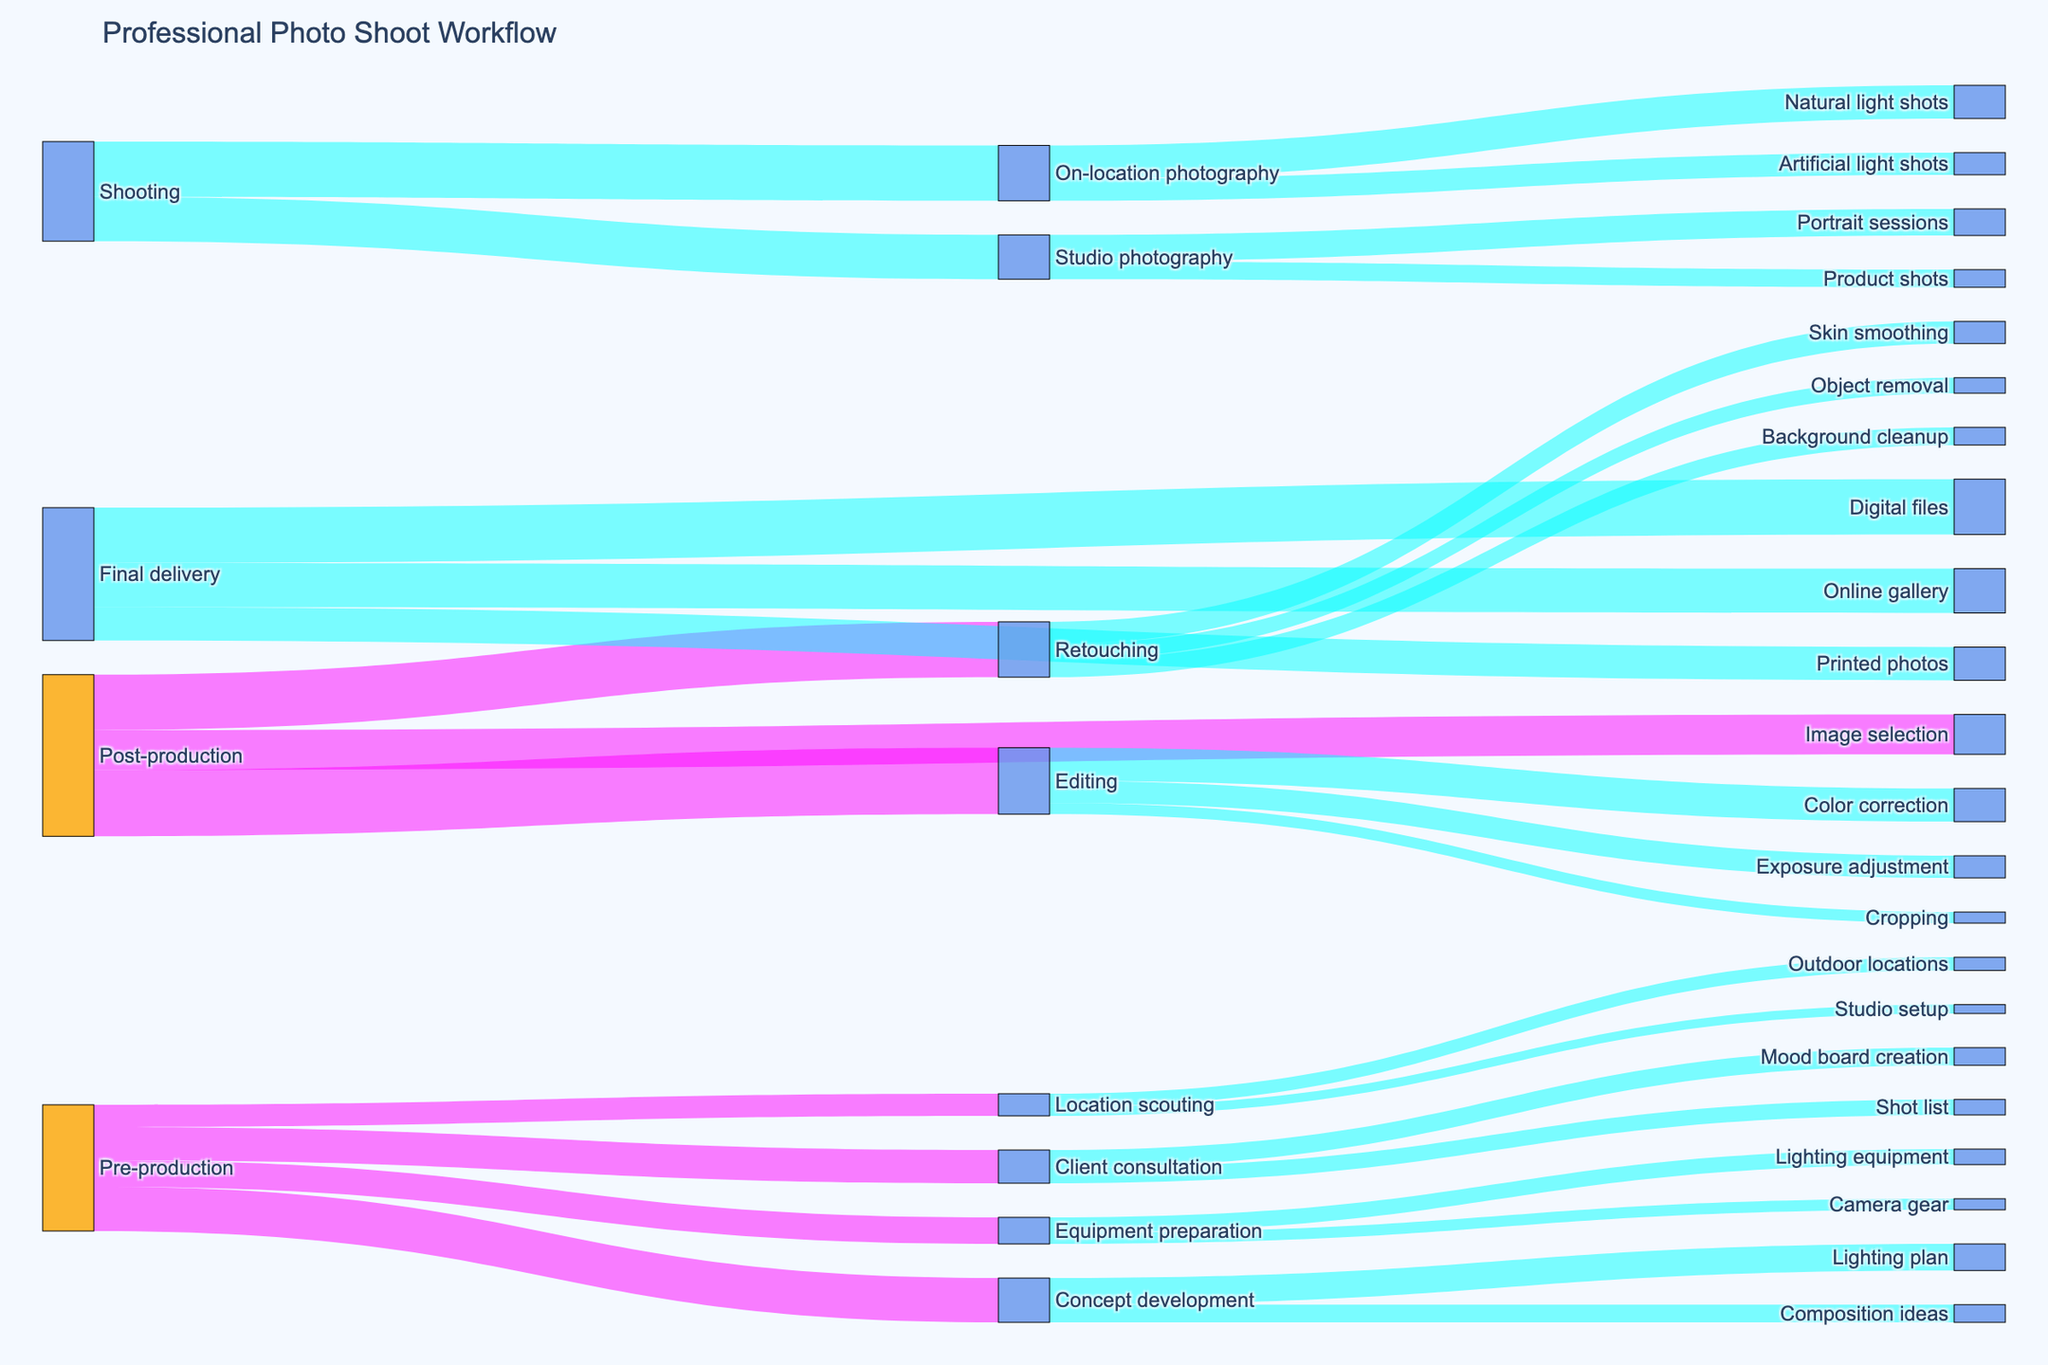What is the title of the Sankey diagram? The title is usually placed at the top of the diagram and describes the overall subject of the visualization.
Answer: Professional Photo Shoot Workflow Which two steps in pre-production have the highest values? By examining the connections originating from the pre-production node, you can identify the values associated with each sub-step. The highest values are Concept development (20) and Client consultation (15).
Answer: Concept development and Client consultation How many connections are there in total from Pre-production to subsequent steps? By counting the arrows originating from the Pre-production node, we can tally the total number of direct connections. There are four connections: Location scouting, Client consultation, Concept development, and Equipment preparation.
Answer: 4 Summing up all the values, what is the total flow from Post-production? The flows from Post-production lead to three target nodes: Image selection (18), Editing (30), and Retouching (25). Adding these values gives 18 + 30 + 25 = 73.
Answer: 73 Compare On-location photography and Studio photography: which has a higher total flow and by how much? We add the values of sub-flows for each type. On-location photography has 15 (Natural light) + 10 (Artificial light) = 25. Studio photography has 12 (Portrait sessions) + 8 (Product shots) = 20. Thus, On-location photography is higher by 25 - 20 = 5.
Answer: On-location photography by 5 Which step has the highest individual flow value in the entire workflow? We need to look for the largest number associated with any single flow. The highest value is 30, from Post-production to Editing.
Answer: Editing What are the two final delivery methods with the highest values? By examining the values associated with the connections to Final delivery, the two largest values are Digital files (25) and Online gallery (20).
Answer: Digital files and Online gallery What is the total value associated with Retouching activities? Adding up all values for the Retouching targets: Skin smoothing (10), Background cleanup (8), and Object removal (7), we get 10 + 8 + 7 = 25.
Answer: 25 If we remove Equipment preparation, what would be the new total value for Pre-production flows? The current total for Pre-production flows is 10 (Location scouting) + 15 (Client consultation) + 20 (Concept development) + 12 (Equipment preparation) = 57. Removing Equipment preparation (12) leaves us with 57 - 12 = 45.
Answer: 45 How does the value for Camera gear compare to Lighting equipment in Equipment preparation? Camera gear has a value of 5, and Lighting equipment has 7. Lighting equipment is higher by 7 - 5 = 2.
Answer: Lighting equipment by 2 